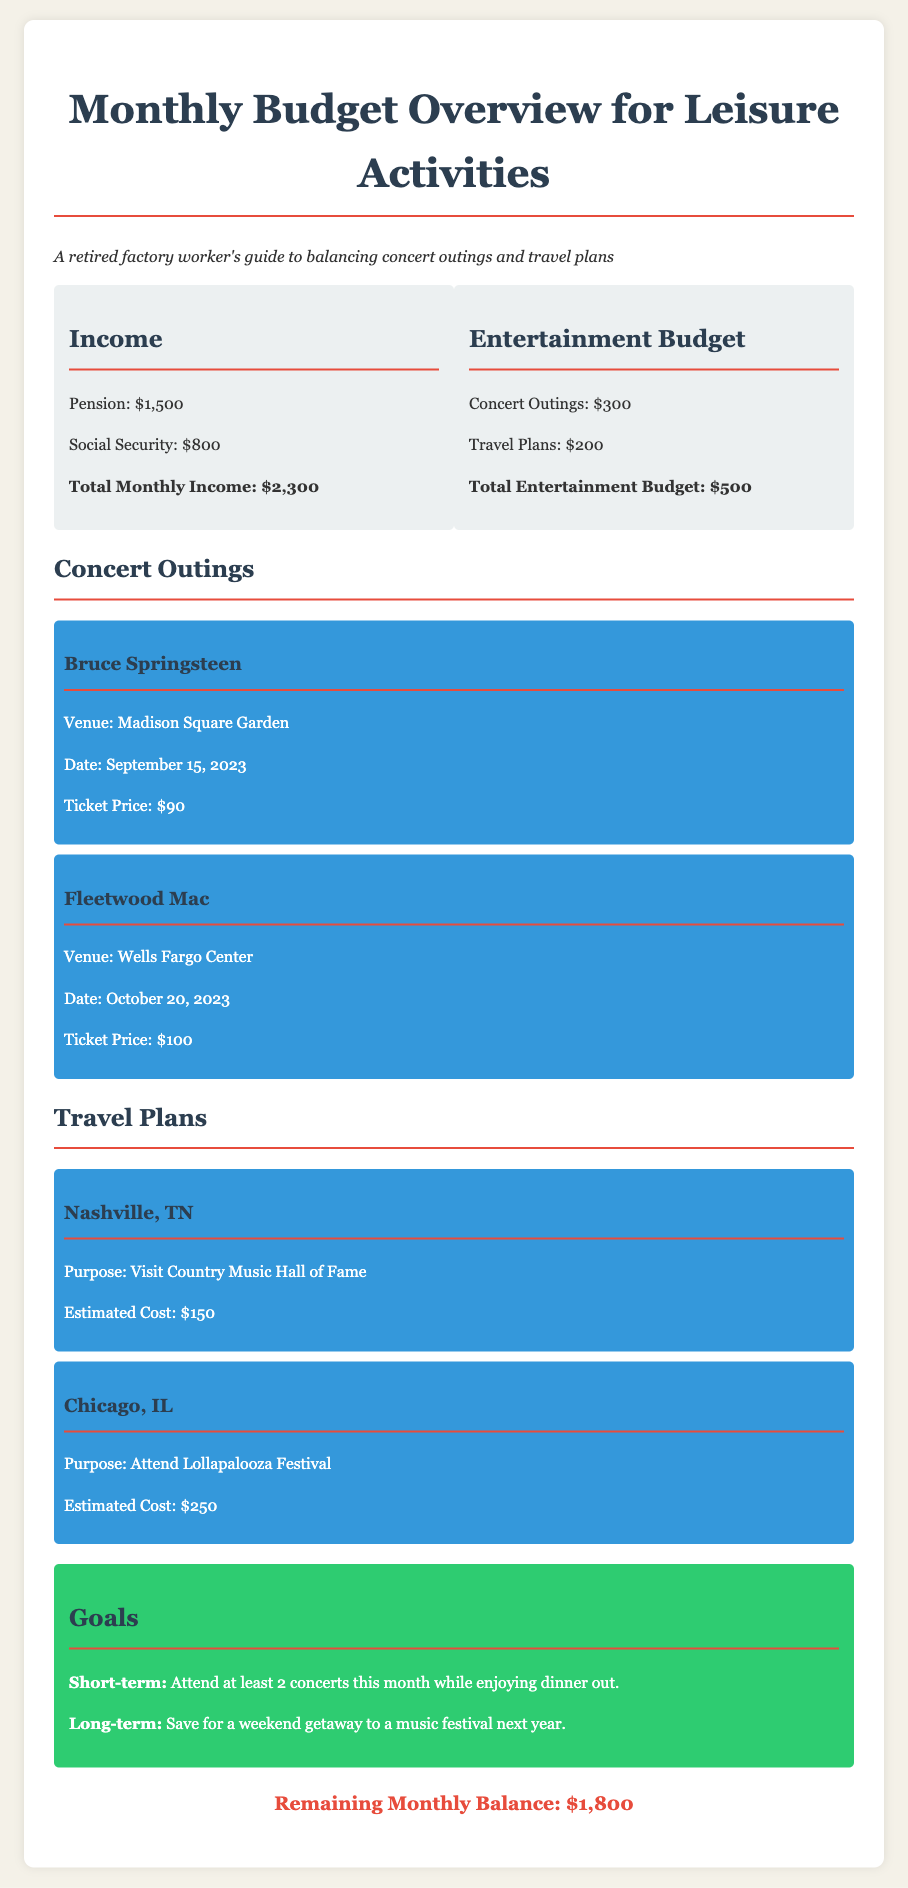What is the total monthly income? The total monthly income is calculated by adding pension and social security, which is $1500 + $800 = $2300.
Answer: $2,300 How much is allocated for concert outings? The expense for concert outings is specified in the budget overview.
Answer: $300 Who is performing on September 15, 2023? The document lists the concert details, including the artist and date.
Answer: Bruce Springsteen What is the estimated cost for the trip to Nashville, TN? The estimated cost for Nashville is listed under travel plans.
Answer: $150 What is the goal for short-term leisure activities? The short-term goal is stated in the goals section of the document.
Answer: Attend at least 2 concerts this month while enjoying dinner out How much is the ticket price for Fleetwood Mac's concert? The document specifies the ticket price next to the concert details.
Answer: $100 What is the remaining monthly balance after expenses? The remaining balance is calculated by subtracting entertainment expenses from total monthly income.
Answer: $1,800 What is the purpose of the trip to Chicago, IL? The purpose of the trip is indicated in the travel plans section.
Answer: Attend Lollapalooza Festival How many concerts are planned this month? The number of concerts is indicated in the concert outings section and the goals section.
Answer: 2 